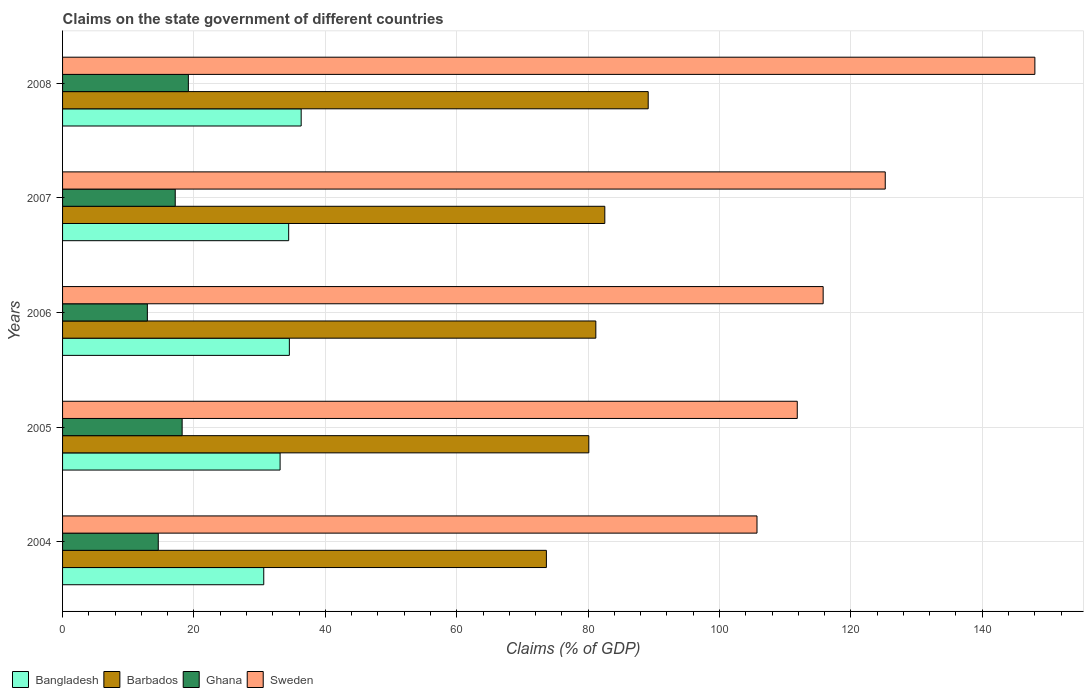How many different coloured bars are there?
Keep it short and to the point. 4. Are the number of bars per tick equal to the number of legend labels?
Offer a terse response. Yes. How many bars are there on the 2nd tick from the bottom?
Provide a succinct answer. 4. What is the label of the 1st group of bars from the top?
Your answer should be very brief. 2008. In how many cases, is the number of bars for a given year not equal to the number of legend labels?
Keep it short and to the point. 0. What is the percentage of GDP claimed on the state government in Bangladesh in 2007?
Give a very brief answer. 34.42. Across all years, what is the maximum percentage of GDP claimed on the state government in Barbados?
Give a very brief answer. 89.15. Across all years, what is the minimum percentage of GDP claimed on the state government in Sweden?
Provide a short and direct response. 105.71. In which year was the percentage of GDP claimed on the state government in Sweden minimum?
Provide a short and direct response. 2004. What is the total percentage of GDP claimed on the state government in Sweden in the graph?
Provide a succinct answer. 606.58. What is the difference between the percentage of GDP claimed on the state government in Barbados in 2006 and that in 2008?
Offer a terse response. -7.97. What is the difference between the percentage of GDP claimed on the state government in Bangladesh in 2004 and the percentage of GDP claimed on the state government in Sweden in 2007?
Your response must be concise. -94.61. What is the average percentage of GDP claimed on the state government in Barbados per year?
Your answer should be compact. 81.33. In the year 2006, what is the difference between the percentage of GDP claimed on the state government in Ghana and percentage of GDP claimed on the state government in Sweden?
Make the answer very short. -102.88. What is the ratio of the percentage of GDP claimed on the state government in Sweden in 2004 to that in 2005?
Keep it short and to the point. 0.95. What is the difference between the highest and the second highest percentage of GDP claimed on the state government in Barbados?
Your answer should be compact. 6.61. What is the difference between the highest and the lowest percentage of GDP claimed on the state government in Bangladesh?
Give a very brief answer. 5.7. In how many years, is the percentage of GDP claimed on the state government in Ghana greater than the average percentage of GDP claimed on the state government in Ghana taken over all years?
Give a very brief answer. 3. Is it the case that in every year, the sum of the percentage of GDP claimed on the state government in Barbados and percentage of GDP claimed on the state government in Sweden is greater than the sum of percentage of GDP claimed on the state government in Bangladesh and percentage of GDP claimed on the state government in Ghana?
Offer a terse response. No. What does the 4th bar from the bottom in 2008 represents?
Make the answer very short. Sweden. Are all the bars in the graph horizontal?
Ensure brevity in your answer.  Yes. Does the graph contain any zero values?
Your response must be concise. No. Where does the legend appear in the graph?
Make the answer very short. Bottom left. How many legend labels are there?
Provide a succinct answer. 4. How are the legend labels stacked?
Keep it short and to the point. Horizontal. What is the title of the graph?
Offer a terse response. Claims on the state government of different countries. Does "Ireland" appear as one of the legend labels in the graph?
Keep it short and to the point. No. What is the label or title of the X-axis?
Offer a very short reply. Claims (% of GDP). What is the Claims (% of GDP) of Bangladesh in 2004?
Provide a succinct answer. 30.62. What is the Claims (% of GDP) of Barbados in 2004?
Your answer should be very brief. 73.65. What is the Claims (% of GDP) of Ghana in 2004?
Give a very brief answer. 14.57. What is the Claims (% of GDP) of Sweden in 2004?
Your response must be concise. 105.71. What is the Claims (% of GDP) in Bangladesh in 2005?
Keep it short and to the point. 33.11. What is the Claims (% of GDP) in Barbados in 2005?
Provide a short and direct response. 80.11. What is the Claims (% of GDP) in Ghana in 2005?
Ensure brevity in your answer.  18.2. What is the Claims (% of GDP) in Sweden in 2005?
Offer a very short reply. 111.84. What is the Claims (% of GDP) in Bangladesh in 2006?
Your answer should be very brief. 34.52. What is the Claims (% of GDP) of Barbados in 2006?
Offer a terse response. 81.18. What is the Claims (% of GDP) of Ghana in 2006?
Keep it short and to the point. 12.91. What is the Claims (% of GDP) of Sweden in 2006?
Offer a terse response. 115.78. What is the Claims (% of GDP) in Bangladesh in 2007?
Offer a terse response. 34.42. What is the Claims (% of GDP) of Barbados in 2007?
Ensure brevity in your answer.  82.54. What is the Claims (% of GDP) of Ghana in 2007?
Make the answer very short. 17.15. What is the Claims (% of GDP) of Sweden in 2007?
Provide a short and direct response. 125.23. What is the Claims (% of GDP) of Bangladesh in 2008?
Offer a terse response. 36.32. What is the Claims (% of GDP) in Barbados in 2008?
Your response must be concise. 89.15. What is the Claims (% of GDP) in Ghana in 2008?
Provide a short and direct response. 19.15. What is the Claims (% of GDP) of Sweden in 2008?
Give a very brief answer. 148.01. Across all years, what is the maximum Claims (% of GDP) in Bangladesh?
Keep it short and to the point. 36.32. Across all years, what is the maximum Claims (% of GDP) in Barbados?
Keep it short and to the point. 89.15. Across all years, what is the maximum Claims (% of GDP) of Ghana?
Offer a very short reply. 19.15. Across all years, what is the maximum Claims (% of GDP) of Sweden?
Give a very brief answer. 148.01. Across all years, what is the minimum Claims (% of GDP) of Bangladesh?
Your answer should be very brief. 30.62. Across all years, what is the minimum Claims (% of GDP) of Barbados?
Your answer should be very brief. 73.65. Across all years, what is the minimum Claims (% of GDP) of Ghana?
Your response must be concise. 12.91. Across all years, what is the minimum Claims (% of GDP) in Sweden?
Your response must be concise. 105.71. What is the total Claims (% of GDP) in Bangladesh in the graph?
Keep it short and to the point. 169. What is the total Claims (% of GDP) in Barbados in the graph?
Your answer should be compact. 406.63. What is the total Claims (% of GDP) in Ghana in the graph?
Your answer should be compact. 81.98. What is the total Claims (% of GDP) in Sweden in the graph?
Provide a short and direct response. 606.58. What is the difference between the Claims (% of GDP) in Bangladesh in 2004 and that in 2005?
Your answer should be compact. -2.49. What is the difference between the Claims (% of GDP) of Barbados in 2004 and that in 2005?
Give a very brief answer. -6.46. What is the difference between the Claims (% of GDP) in Ghana in 2004 and that in 2005?
Your response must be concise. -3.63. What is the difference between the Claims (% of GDP) in Sweden in 2004 and that in 2005?
Keep it short and to the point. -6.13. What is the difference between the Claims (% of GDP) of Bangladesh in 2004 and that in 2006?
Your answer should be very brief. -3.9. What is the difference between the Claims (% of GDP) of Barbados in 2004 and that in 2006?
Provide a succinct answer. -7.53. What is the difference between the Claims (% of GDP) in Ghana in 2004 and that in 2006?
Make the answer very short. 1.66. What is the difference between the Claims (% of GDP) in Sweden in 2004 and that in 2006?
Provide a succinct answer. -10.07. What is the difference between the Claims (% of GDP) in Bangladesh in 2004 and that in 2007?
Offer a very short reply. -3.79. What is the difference between the Claims (% of GDP) in Barbados in 2004 and that in 2007?
Keep it short and to the point. -8.89. What is the difference between the Claims (% of GDP) in Ghana in 2004 and that in 2007?
Offer a very short reply. -2.58. What is the difference between the Claims (% of GDP) in Sweden in 2004 and that in 2007?
Keep it short and to the point. -19.52. What is the difference between the Claims (% of GDP) of Bangladesh in 2004 and that in 2008?
Provide a short and direct response. -5.7. What is the difference between the Claims (% of GDP) of Barbados in 2004 and that in 2008?
Your answer should be very brief. -15.5. What is the difference between the Claims (% of GDP) in Ghana in 2004 and that in 2008?
Keep it short and to the point. -4.58. What is the difference between the Claims (% of GDP) of Sweden in 2004 and that in 2008?
Ensure brevity in your answer.  -42.3. What is the difference between the Claims (% of GDP) of Bangladesh in 2005 and that in 2006?
Offer a very short reply. -1.41. What is the difference between the Claims (% of GDP) in Barbados in 2005 and that in 2006?
Keep it short and to the point. -1.07. What is the difference between the Claims (% of GDP) of Ghana in 2005 and that in 2006?
Keep it short and to the point. 5.3. What is the difference between the Claims (% of GDP) of Sweden in 2005 and that in 2006?
Keep it short and to the point. -3.94. What is the difference between the Claims (% of GDP) of Bangladesh in 2005 and that in 2007?
Your answer should be compact. -1.3. What is the difference between the Claims (% of GDP) in Barbados in 2005 and that in 2007?
Provide a short and direct response. -2.43. What is the difference between the Claims (% of GDP) of Ghana in 2005 and that in 2007?
Your answer should be compact. 1.05. What is the difference between the Claims (% of GDP) in Sweden in 2005 and that in 2007?
Ensure brevity in your answer.  -13.39. What is the difference between the Claims (% of GDP) of Bangladesh in 2005 and that in 2008?
Ensure brevity in your answer.  -3.21. What is the difference between the Claims (% of GDP) of Barbados in 2005 and that in 2008?
Keep it short and to the point. -9.04. What is the difference between the Claims (% of GDP) of Ghana in 2005 and that in 2008?
Provide a short and direct response. -0.95. What is the difference between the Claims (% of GDP) in Sweden in 2005 and that in 2008?
Offer a terse response. -36.17. What is the difference between the Claims (% of GDP) in Bangladesh in 2006 and that in 2007?
Give a very brief answer. 0.11. What is the difference between the Claims (% of GDP) in Barbados in 2006 and that in 2007?
Make the answer very short. -1.37. What is the difference between the Claims (% of GDP) in Ghana in 2006 and that in 2007?
Make the answer very short. -4.24. What is the difference between the Claims (% of GDP) of Sweden in 2006 and that in 2007?
Keep it short and to the point. -9.45. What is the difference between the Claims (% of GDP) in Bangladesh in 2006 and that in 2008?
Keep it short and to the point. -1.8. What is the difference between the Claims (% of GDP) in Barbados in 2006 and that in 2008?
Give a very brief answer. -7.97. What is the difference between the Claims (% of GDP) in Ghana in 2006 and that in 2008?
Give a very brief answer. -6.24. What is the difference between the Claims (% of GDP) of Sweden in 2006 and that in 2008?
Give a very brief answer. -32.23. What is the difference between the Claims (% of GDP) of Bangladesh in 2007 and that in 2008?
Provide a short and direct response. -1.9. What is the difference between the Claims (% of GDP) of Barbados in 2007 and that in 2008?
Offer a terse response. -6.61. What is the difference between the Claims (% of GDP) in Ghana in 2007 and that in 2008?
Keep it short and to the point. -2. What is the difference between the Claims (% of GDP) in Sweden in 2007 and that in 2008?
Provide a short and direct response. -22.78. What is the difference between the Claims (% of GDP) of Bangladesh in 2004 and the Claims (% of GDP) of Barbados in 2005?
Make the answer very short. -49.48. What is the difference between the Claims (% of GDP) in Bangladesh in 2004 and the Claims (% of GDP) in Ghana in 2005?
Provide a succinct answer. 12.42. What is the difference between the Claims (% of GDP) of Bangladesh in 2004 and the Claims (% of GDP) of Sweden in 2005?
Offer a very short reply. -81.22. What is the difference between the Claims (% of GDP) in Barbados in 2004 and the Claims (% of GDP) in Ghana in 2005?
Offer a very short reply. 55.45. What is the difference between the Claims (% of GDP) in Barbados in 2004 and the Claims (% of GDP) in Sweden in 2005?
Your answer should be very brief. -38.19. What is the difference between the Claims (% of GDP) in Ghana in 2004 and the Claims (% of GDP) in Sweden in 2005?
Ensure brevity in your answer.  -97.27. What is the difference between the Claims (% of GDP) in Bangladesh in 2004 and the Claims (% of GDP) in Barbados in 2006?
Provide a short and direct response. -50.55. What is the difference between the Claims (% of GDP) of Bangladesh in 2004 and the Claims (% of GDP) of Ghana in 2006?
Your response must be concise. 17.72. What is the difference between the Claims (% of GDP) in Bangladesh in 2004 and the Claims (% of GDP) in Sweden in 2006?
Provide a succinct answer. -85.16. What is the difference between the Claims (% of GDP) of Barbados in 2004 and the Claims (% of GDP) of Ghana in 2006?
Your answer should be compact. 60.74. What is the difference between the Claims (% of GDP) of Barbados in 2004 and the Claims (% of GDP) of Sweden in 2006?
Your answer should be very brief. -42.13. What is the difference between the Claims (% of GDP) of Ghana in 2004 and the Claims (% of GDP) of Sweden in 2006?
Make the answer very short. -101.21. What is the difference between the Claims (% of GDP) in Bangladesh in 2004 and the Claims (% of GDP) in Barbados in 2007?
Offer a very short reply. -51.92. What is the difference between the Claims (% of GDP) in Bangladesh in 2004 and the Claims (% of GDP) in Ghana in 2007?
Your response must be concise. 13.47. What is the difference between the Claims (% of GDP) in Bangladesh in 2004 and the Claims (% of GDP) in Sweden in 2007?
Your answer should be very brief. -94.61. What is the difference between the Claims (% of GDP) in Barbados in 2004 and the Claims (% of GDP) in Ghana in 2007?
Give a very brief answer. 56.5. What is the difference between the Claims (% of GDP) of Barbados in 2004 and the Claims (% of GDP) of Sweden in 2007?
Make the answer very short. -51.58. What is the difference between the Claims (% of GDP) of Ghana in 2004 and the Claims (% of GDP) of Sweden in 2007?
Give a very brief answer. -110.66. What is the difference between the Claims (% of GDP) in Bangladesh in 2004 and the Claims (% of GDP) in Barbados in 2008?
Your response must be concise. -58.52. What is the difference between the Claims (% of GDP) of Bangladesh in 2004 and the Claims (% of GDP) of Ghana in 2008?
Give a very brief answer. 11.47. What is the difference between the Claims (% of GDP) in Bangladesh in 2004 and the Claims (% of GDP) in Sweden in 2008?
Give a very brief answer. -117.39. What is the difference between the Claims (% of GDP) of Barbados in 2004 and the Claims (% of GDP) of Ghana in 2008?
Your answer should be very brief. 54.5. What is the difference between the Claims (% of GDP) of Barbados in 2004 and the Claims (% of GDP) of Sweden in 2008?
Make the answer very short. -74.36. What is the difference between the Claims (% of GDP) in Ghana in 2004 and the Claims (% of GDP) in Sweden in 2008?
Provide a succinct answer. -133.44. What is the difference between the Claims (% of GDP) of Bangladesh in 2005 and the Claims (% of GDP) of Barbados in 2006?
Your answer should be compact. -48.06. What is the difference between the Claims (% of GDP) of Bangladesh in 2005 and the Claims (% of GDP) of Ghana in 2006?
Provide a succinct answer. 20.21. What is the difference between the Claims (% of GDP) in Bangladesh in 2005 and the Claims (% of GDP) in Sweden in 2006?
Provide a succinct answer. -82.67. What is the difference between the Claims (% of GDP) in Barbados in 2005 and the Claims (% of GDP) in Ghana in 2006?
Offer a terse response. 67.2. What is the difference between the Claims (% of GDP) in Barbados in 2005 and the Claims (% of GDP) in Sweden in 2006?
Offer a terse response. -35.67. What is the difference between the Claims (% of GDP) in Ghana in 2005 and the Claims (% of GDP) in Sweden in 2006?
Give a very brief answer. -97.58. What is the difference between the Claims (% of GDP) of Bangladesh in 2005 and the Claims (% of GDP) of Barbados in 2007?
Your response must be concise. -49.43. What is the difference between the Claims (% of GDP) in Bangladesh in 2005 and the Claims (% of GDP) in Ghana in 2007?
Your answer should be very brief. 15.96. What is the difference between the Claims (% of GDP) in Bangladesh in 2005 and the Claims (% of GDP) in Sweden in 2007?
Keep it short and to the point. -92.12. What is the difference between the Claims (% of GDP) in Barbados in 2005 and the Claims (% of GDP) in Ghana in 2007?
Offer a very short reply. 62.96. What is the difference between the Claims (% of GDP) of Barbados in 2005 and the Claims (% of GDP) of Sweden in 2007?
Your answer should be compact. -45.12. What is the difference between the Claims (% of GDP) in Ghana in 2005 and the Claims (% of GDP) in Sweden in 2007?
Your answer should be very brief. -107.03. What is the difference between the Claims (% of GDP) in Bangladesh in 2005 and the Claims (% of GDP) in Barbados in 2008?
Your response must be concise. -56.04. What is the difference between the Claims (% of GDP) of Bangladesh in 2005 and the Claims (% of GDP) of Ghana in 2008?
Your response must be concise. 13.96. What is the difference between the Claims (% of GDP) of Bangladesh in 2005 and the Claims (% of GDP) of Sweden in 2008?
Provide a short and direct response. -114.9. What is the difference between the Claims (% of GDP) of Barbados in 2005 and the Claims (% of GDP) of Ghana in 2008?
Your answer should be compact. 60.96. What is the difference between the Claims (% of GDP) of Barbados in 2005 and the Claims (% of GDP) of Sweden in 2008?
Offer a terse response. -67.9. What is the difference between the Claims (% of GDP) in Ghana in 2005 and the Claims (% of GDP) in Sweden in 2008?
Your answer should be compact. -129.81. What is the difference between the Claims (% of GDP) of Bangladesh in 2006 and the Claims (% of GDP) of Barbados in 2007?
Your answer should be very brief. -48.02. What is the difference between the Claims (% of GDP) of Bangladesh in 2006 and the Claims (% of GDP) of Ghana in 2007?
Keep it short and to the point. 17.37. What is the difference between the Claims (% of GDP) in Bangladesh in 2006 and the Claims (% of GDP) in Sweden in 2007?
Make the answer very short. -90.71. What is the difference between the Claims (% of GDP) of Barbados in 2006 and the Claims (% of GDP) of Ghana in 2007?
Give a very brief answer. 64.03. What is the difference between the Claims (% of GDP) of Barbados in 2006 and the Claims (% of GDP) of Sweden in 2007?
Ensure brevity in your answer.  -44.06. What is the difference between the Claims (% of GDP) in Ghana in 2006 and the Claims (% of GDP) in Sweden in 2007?
Provide a short and direct response. -112.33. What is the difference between the Claims (% of GDP) of Bangladesh in 2006 and the Claims (% of GDP) of Barbados in 2008?
Offer a very short reply. -54.62. What is the difference between the Claims (% of GDP) of Bangladesh in 2006 and the Claims (% of GDP) of Ghana in 2008?
Offer a very short reply. 15.37. What is the difference between the Claims (% of GDP) of Bangladesh in 2006 and the Claims (% of GDP) of Sweden in 2008?
Your answer should be very brief. -113.49. What is the difference between the Claims (% of GDP) of Barbados in 2006 and the Claims (% of GDP) of Ghana in 2008?
Offer a very short reply. 62.03. What is the difference between the Claims (% of GDP) of Barbados in 2006 and the Claims (% of GDP) of Sweden in 2008?
Provide a short and direct response. -66.83. What is the difference between the Claims (% of GDP) of Ghana in 2006 and the Claims (% of GDP) of Sweden in 2008?
Your response must be concise. -135.1. What is the difference between the Claims (% of GDP) of Bangladesh in 2007 and the Claims (% of GDP) of Barbados in 2008?
Keep it short and to the point. -54.73. What is the difference between the Claims (% of GDP) in Bangladesh in 2007 and the Claims (% of GDP) in Ghana in 2008?
Your answer should be very brief. 15.27. What is the difference between the Claims (% of GDP) in Bangladesh in 2007 and the Claims (% of GDP) in Sweden in 2008?
Your response must be concise. -113.59. What is the difference between the Claims (% of GDP) of Barbados in 2007 and the Claims (% of GDP) of Ghana in 2008?
Provide a short and direct response. 63.39. What is the difference between the Claims (% of GDP) of Barbados in 2007 and the Claims (% of GDP) of Sweden in 2008?
Ensure brevity in your answer.  -65.47. What is the difference between the Claims (% of GDP) in Ghana in 2007 and the Claims (% of GDP) in Sweden in 2008?
Provide a succinct answer. -130.86. What is the average Claims (% of GDP) in Bangladesh per year?
Offer a terse response. 33.8. What is the average Claims (% of GDP) in Barbados per year?
Your answer should be very brief. 81.33. What is the average Claims (% of GDP) in Ghana per year?
Give a very brief answer. 16.4. What is the average Claims (% of GDP) in Sweden per year?
Ensure brevity in your answer.  121.32. In the year 2004, what is the difference between the Claims (% of GDP) of Bangladesh and Claims (% of GDP) of Barbados?
Make the answer very short. -43.03. In the year 2004, what is the difference between the Claims (% of GDP) of Bangladesh and Claims (% of GDP) of Ghana?
Keep it short and to the point. 16.06. In the year 2004, what is the difference between the Claims (% of GDP) in Bangladesh and Claims (% of GDP) in Sweden?
Ensure brevity in your answer.  -75.09. In the year 2004, what is the difference between the Claims (% of GDP) of Barbados and Claims (% of GDP) of Ghana?
Keep it short and to the point. 59.08. In the year 2004, what is the difference between the Claims (% of GDP) in Barbados and Claims (% of GDP) in Sweden?
Your answer should be compact. -32.06. In the year 2004, what is the difference between the Claims (% of GDP) in Ghana and Claims (% of GDP) in Sweden?
Keep it short and to the point. -91.14. In the year 2005, what is the difference between the Claims (% of GDP) of Bangladesh and Claims (% of GDP) of Barbados?
Provide a succinct answer. -46.99. In the year 2005, what is the difference between the Claims (% of GDP) in Bangladesh and Claims (% of GDP) in Ghana?
Offer a terse response. 14.91. In the year 2005, what is the difference between the Claims (% of GDP) of Bangladesh and Claims (% of GDP) of Sweden?
Your response must be concise. -78.73. In the year 2005, what is the difference between the Claims (% of GDP) in Barbados and Claims (% of GDP) in Ghana?
Provide a short and direct response. 61.91. In the year 2005, what is the difference between the Claims (% of GDP) in Barbados and Claims (% of GDP) in Sweden?
Your answer should be very brief. -31.73. In the year 2005, what is the difference between the Claims (% of GDP) in Ghana and Claims (% of GDP) in Sweden?
Offer a very short reply. -93.64. In the year 2006, what is the difference between the Claims (% of GDP) of Bangladesh and Claims (% of GDP) of Barbados?
Keep it short and to the point. -46.65. In the year 2006, what is the difference between the Claims (% of GDP) in Bangladesh and Claims (% of GDP) in Ghana?
Ensure brevity in your answer.  21.62. In the year 2006, what is the difference between the Claims (% of GDP) in Bangladesh and Claims (% of GDP) in Sweden?
Your answer should be very brief. -81.26. In the year 2006, what is the difference between the Claims (% of GDP) in Barbados and Claims (% of GDP) in Ghana?
Your answer should be very brief. 68.27. In the year 2006, what is the difference between the Claims (% of GDP) of Barbados and Claims (% of GDP) of Sweden?
Your answer should be very brief. -34.61. In the year 2006, what is the difference between the Claims (% of GDP) in Ghana and Claims (% of GDP) in Sweden?
Your answer should be very brief. -102.88. In the year 2007, what is the difference between the Claims (% of GDP) of Bangladesh and Claims (% of GDP) of Barbados?
Your answer should be compact. -48.12. In the year 2007, what is the difference between the Claims (% of GDP) of Bangladesh and Claims (% of GDP) of Ghana?
Offer a terse response. 17.27. In the year 2007, what is the difference between the Claims (% of GDP) in Bangladesh and Claims (% of GDP) in Sweden?
Your answer should be very brief. -90.81. In the year 2007, what is the difference between the Claims (% of GDP) in Barbados and Claims (% of GDP) in Ghana?
Offer a terse response. 65.39. In the year 2007, what is the difference between the Claims (% of GDP) of Barbados and Claims (% of GDP) of Sweden?
Provide a succinct answer. -42.69. In the year 2007, what is the difference between the Claims (% of GDP) of Ghana and Claims (% of GDP) of Sweden?
Give a very brief answer. -108.08. In the year 2008, what is the difference between the Claims (% of GDP) in Bangladesh and Claims (% of GDP) in Barbados?
Your answer should be compact. -52.83. In the year 2008, what is the difference between the Claims (% of GDP) in Bangladesh and Claims (% of GDP) in Ghana?
Make the answer very short. 17.17. In the year 2008, what is the difference between the Claims (% of GDP) in Bangladesh and Claims (% of GDP) in Sweden?
Keep it short and to the point. -111.69. In the year 2008, what is the difference between the Claims (% of GDP) in Barbados and Claims (% of GDP) in Ghana?
Provide a short and direct response. 70. In the year 2008, what is the difference between the Claims (% of GDP) in Barbados and Claims (% of GDP) in Sweden?
Make the answer very short. -58.86. In the year 2008, what is the difference between the Claims (% of GDP) in Ghana and Claims (% of GDP) in Sweden?
Offer a terse response. -128.86. What is the ratio of the Claims (% of GDP) of Bangladesh in 2004 to that in 2005?
Keep it short and to the point. 0.92. What is the ratio of the Claims (% of GDP) of Barbados in 2004 to that in 2005?
Offer a terse response. 0.92. What is the ratio of the Claims (% of GDP) in Ghana in 2004 to that in 2005?
Keep it short and to the point. 0.8. What is the ratio of the Claims (% of GDP) of Sweden in 2004 to that in 2005?
Provide a succinct answer. 0.95. What is the ratio of the Claims (% of GDP) of Bangladesh in 2004 to that in 2006?
Your answer should be compact. 0.89. What is the ratio of the Claims (% of GDP) of Barbados in 2004 to that in 2006?
Provide a short and direct response. 0.91. What is the ratio of the Claims (% of GDP) of Ghana in 2004 to that in 2006?
Provide a short and direct response. 1.13. What is the ratio of the Claims (% of GDP) of Sweden in 2004 to that in 2006?
Your answer should be very brief. 0.91. What is the ratio of the Claims (% of GDP) in Bangladesh in 2004 to that in 2007?
Your response must be concise. 0.89. What is the ratio of the Claims (% of GDP) in Barbados in 2004 to that in 2007?
Offer a terse response. 0.89. What is the ratio of the Claims (% of GDP) in Ghana in 2004 to that in 2007?
Your response must be concise. 0.85. What is the ratio of the Claims (% of GDP) of Sweden in 2004 to that in 2007?
Your answer should be very brief. 0.84. What is the ratio of the Claims (% of GDP) in Bangladesh in 2004 to that in 2008?
Ensure brevity in your answer.  0.84. What is the ratio of the Claims (% of GDP) in Barbados in 2004 to that in 2008?
Offer a very short reply. 0.83. What is the ratio of the Claims (% of GDP) in Ghana in 2004 to that in 2008?
Make the answer very short. 0.76. What is the ratio of the Claims (% of GDP) in Sweden in 2004 to that in 2008?
Your response must be concise. 0.71. What is the ratio of the Claims (% of GDP) of Bangladesh in 2005 to that in 2006?
Make the answer very short. 0.96. What is the ratio of the Claims (% of GDP) in Ghana in 2005 to that in 2006?
Make the answer very short. 1.41. What is the ratio of the Claims (% of GDP) of Sweden in 2005 to that in 2006?
Give a very brief answer. 0.97. What is the ratio of the Claims (% of GDP) of Bangladesh in 2005 to that in 2007?
Your answer should be compact. 0.96. What is the ratio of the Claims (% of GDP) in Barbados in 2005 to that in 2007?
Provide a short and direct response. 0.97. What is the ratio of the Claims (% of GDP) of Ghana in 2005 to that in 2007?
Your answer should be compact. 1.06. What is the ratio of the Claims (% of GDP) in Sweden in 2005 to that in 2007?
Offer a terse response. 0.89. What is the ratio of the Claims (% of GDP) in Bangladesh in 2005 to that in 2008?
Your answer should be compact. 0.91. What is the ratio of the Claims (% of GDP) of Barbados in 2005 to that in 2008?
Give a very brief answer. 0.9. What is the ratio of the Claims (% of GDP) in Ghana in 2005 to that in 2008?
Give a very brief answer. 0.95. What is the ratio of the Claims (% of GDP) in Sweden in 2005 to that in 2008?
Provide a succinct answer. 0.76. What is the ratio of the Claims (% of GDP) of Bangladesh in 2006 to that in 2007?
Your response must be concise. 1. What is the ratio of the Claims (% of GDP) in Barbados in 2006 to that in 2007?
Offer a terse response. 0.98. What is the ratio of the Claims (% of GDP) of Ghana in 2006 to that in 2007?
Give a very brief answer. 0.75. What is the ratio of the Claims (% of GDP) in Sweden in 2006 to that in 2007?
Ensure brevity in your answer.  0.92. What is the ratio of the Claims (% of GDP) in Bangladesh in 2006 to that in 2008?
Provide a short and direct response. 0.95. What is the ratio of the Claims (% of GDP) of Barbados in 2006 to that in 2008?
Offer a terse response. 0.91. What is the ratio of the Claims (% of GDP) in Ghana in 2006 to that in 2008?
Make the answer very short. 0.67. What is the ratio of the Claims (% of GDP) in Sweden in 2006 to that in 2008?
Your response must be concise. 0.78. What is the ratio of the Claims (% of GDP) in Bangladesh in 2007 to that in 2008?
Provide a succinct answer. 0.95. What is the ratio of the Claims (% of GDP) in Barbados in 2007 to that in 2008?
Provide a succinct answer. 0.93. What is the ratio of the Claims (% of GDP) in Ghana in 2007 to that in 2008?
Provide a short and direct response. 0.9. What is the ratio of the Claims (% of GDP) in Sweden in 2007 to that in 2008?
Keep it short and to the point. 0.85. What is the difference between the highest and the second highest Claims (% of GDP) of Bangladesh?
Make the answer very short. 1.8. What is the difference between the highest and the second highest Claims (% of GDP) in Barbados?
Offer a very short reply. 6.61. What is the difference between the highest and the second highest Claims (% of GDP) of Ghana?
Keep it short and to the point. 0.95. What is the difference between the highest and the second highest Claims (% of GDP) of Sweden?
Ensure brevity in your answer.  22.78. What is the difference between the highest and the lowest Claims (% of GDP) in Bangladesh?
Your answer should be compact. 5.7. What is the difference between the highest and the lowest Claims (% of GDP) in Barbados?
Offer a very short reply. 15.5. What is the difference between the highest and the lowest Claims (% of GDP) in Ghana?
Offer a terse response. 6.24. What is the difference between the highest and the lowest Claims (% of GDP) in Sweden?
Give a very brief answer. 42.3. 